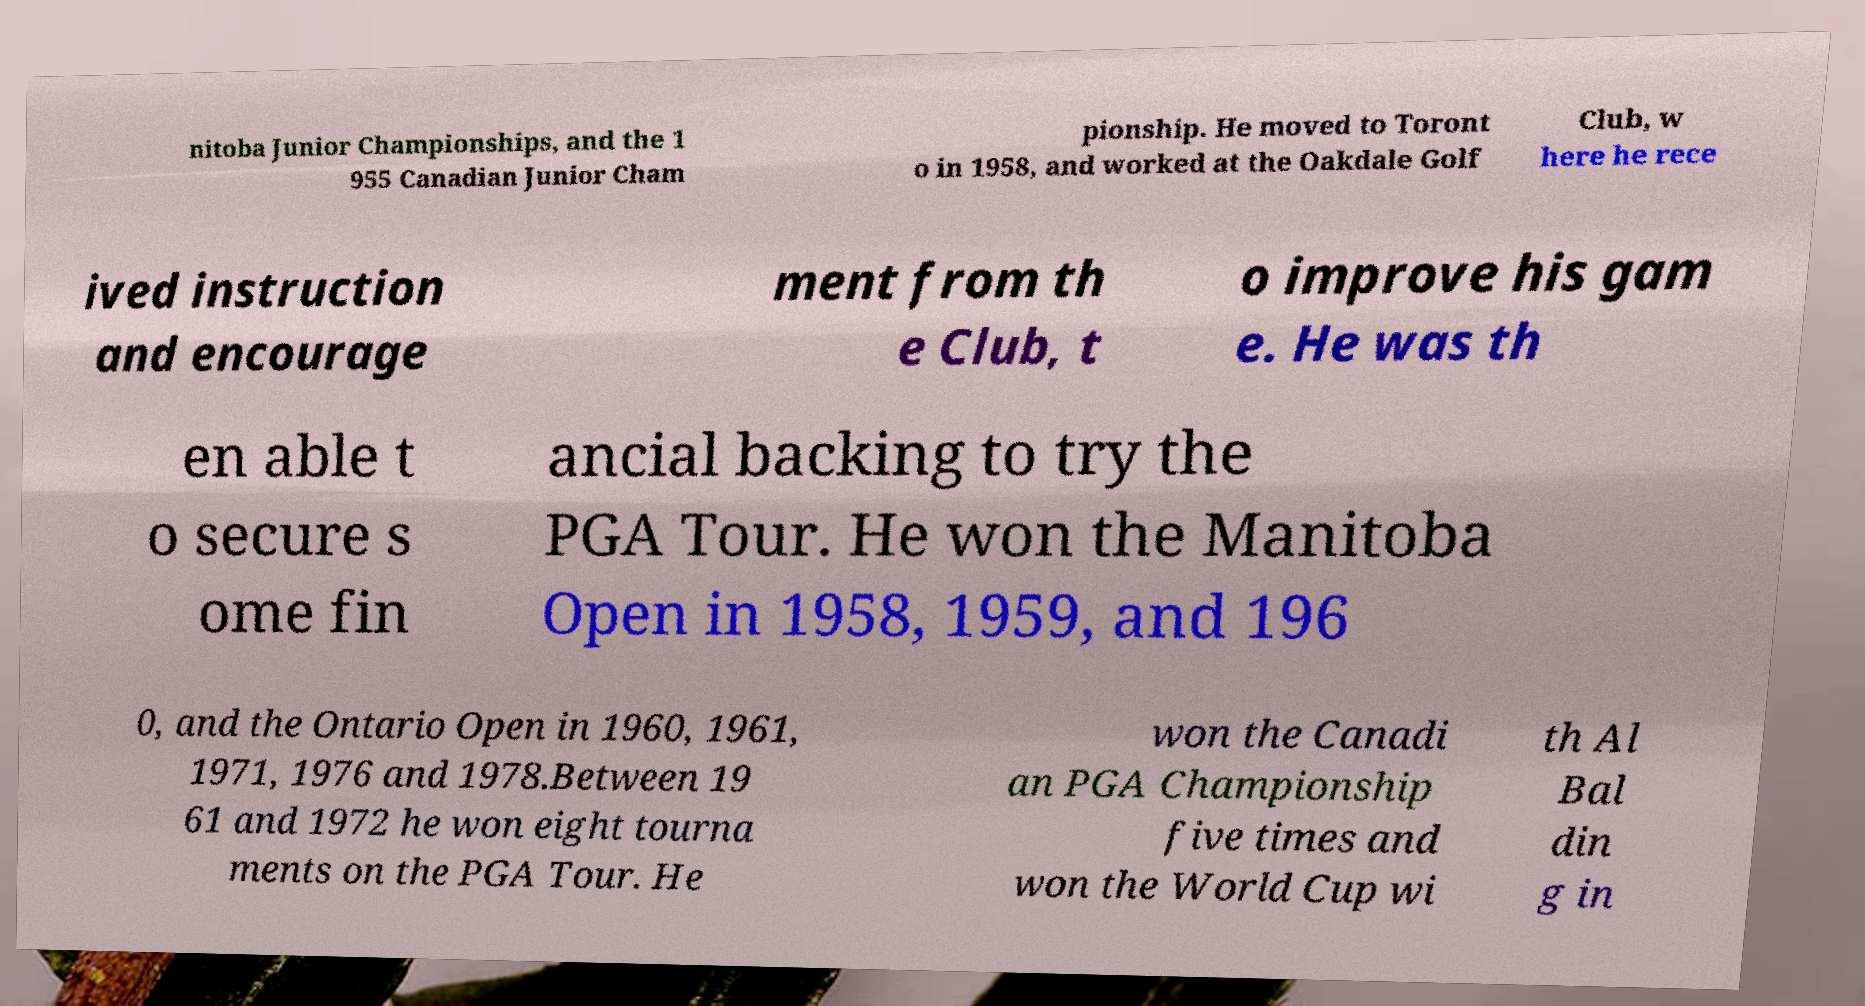Can you accurately transcribe the text from the provided image for me? nitoba Junior Championships, and the 1 955 Canadian Junior Cham pionship. He moved to Toront o in 1958, and worked at the Oakdale Golf Club, w here he rece ived instruction and encourage ment from th e Club, t o improve his gam e. He was th en able t o secure s ome fin ancial backing to try the PGA Tour. He won the Manitoba Open in 1958, 1959, and 196 0, and the Ontario Open in 1960, 1961, 1971, 1976 and 1978.Between 19 61 and 1972 he won eight tourna ments on the PGA Tour. He won the Canadi an PGA Championship five times and won the World Cup wi th Al Bal din g in 